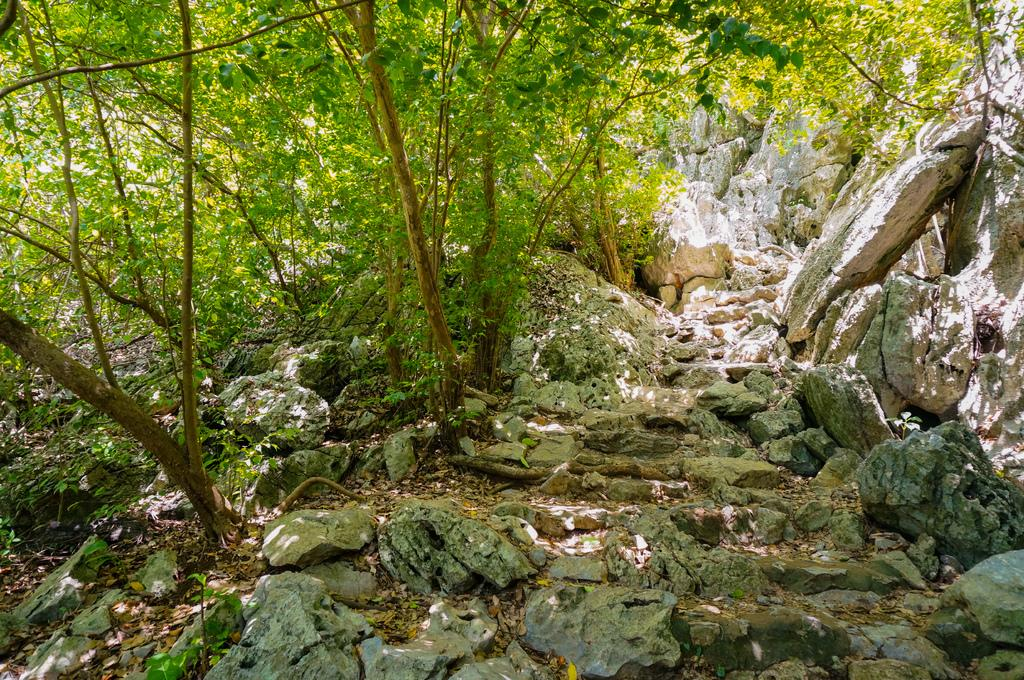What type of vegetation is predominant in the image? There are many trees in the image. What can be seen on the right side of the image? There are stones on the right side of the image. What type of ground cover is present at the bottom of the image? There is grass at the bottom of the image. What else can be found at the bottom of the image? Leaves are present at the bottom of the image. Can you tell me how many cherries are hanging from the trees in the image? There is no mention of cherries in the image; it only features trees, stones, grass, and leaves. Who is the friend that can be seen in the image? There is no person, including a friend, present in the image. 